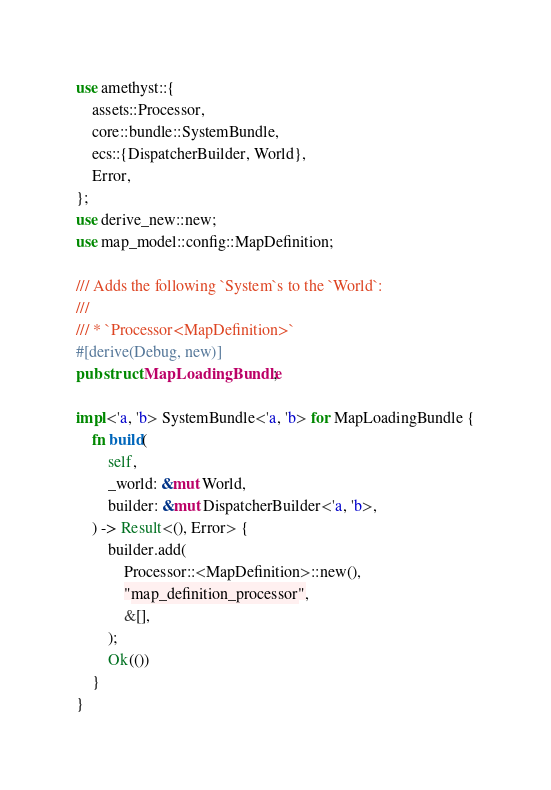Convert code to text. <code><loc_0><loc_0><loc_500><loc_500><_Rust_>use amethyst::{
    assets::Processor,
    core::bundle::SystemBundle,
    ecs::{DispatcherBuilder, World},
    Error,
};
use derive_new::new;
use map_model::config::MapDefinition;

/// Adds the following `System`s to the `World`:
///
/// * `Processor<MapDefinition>`
#[derive(Debug, new)]
pub struct MapLoadingBundle;

impl<'a, 'b> SystemBundle<'a, 'b> for MapLoadingBundle {
    fn build(
        self,
        _world: &mut World,
        builder: &mut DispatcherBuilder<'a, 'b>,
    ) -> Result<(), Error> {
        builder.add(
            Processor::<MapDefinition>::new(),
            "map_definition_processor",
            &[],
        );
        Ok(())
    }
}
</code> 